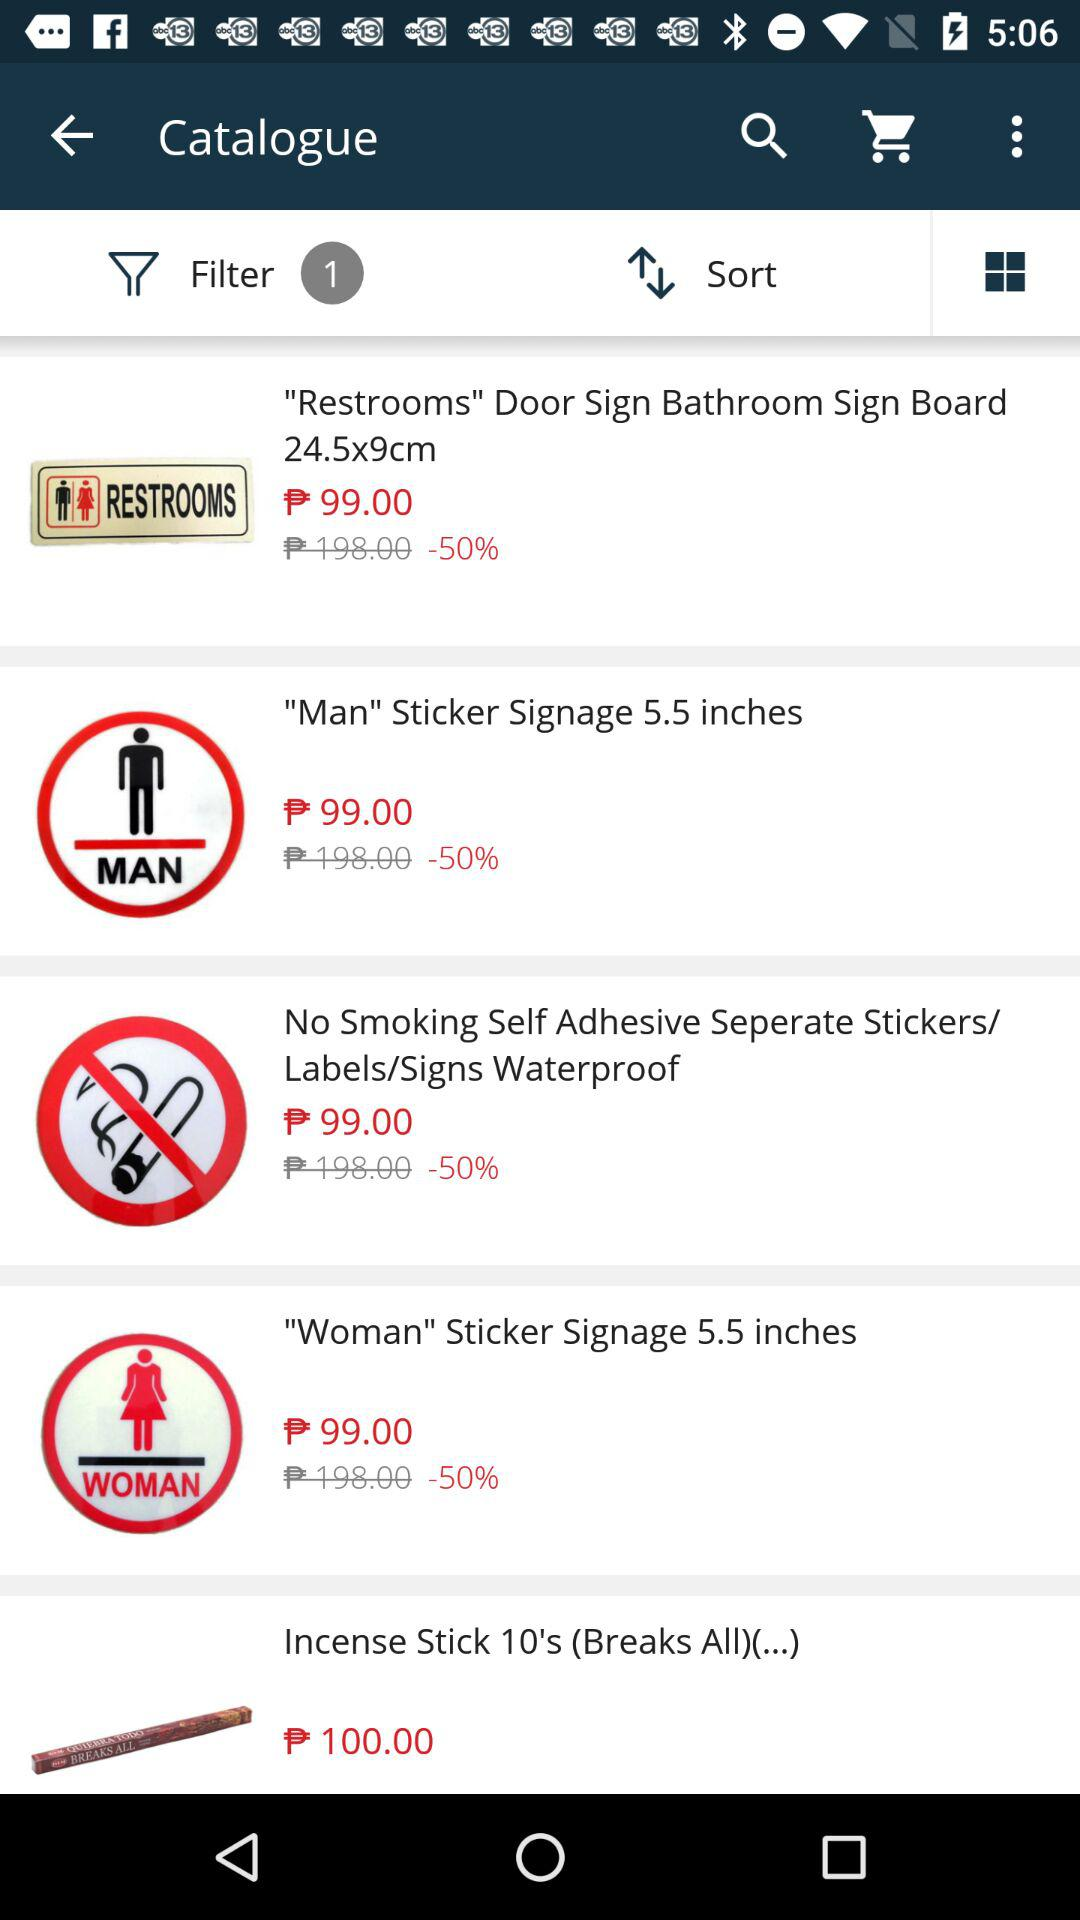How much is the discount on the 'Restrooms' Door Sign Bathroom Sign Board 24.5x9cm?
Answer the question using a single word or phrase. 50% 